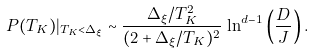Convert formula to latex. <formula><loc_0><loc_0><loc_500><loc_500>P ( T _ { K } ) | _ { T _ { K } < \Delta _ { \xi } } \sim \frac { \Delta _ { \xi } / T _ { K } ^ { 2 } } { ( 2 + \Delta _ { \xi } / T _ { K } ) ^ { 2 } } \, \ln ^ { d - 1 } \left ( \frac { D } { J } \right ) .</formula> 